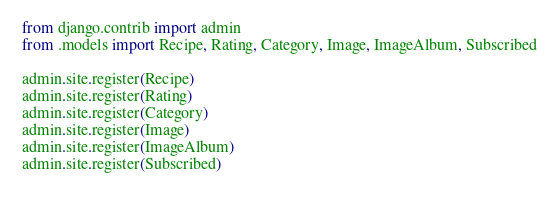<code> <loc_0><loc_0><loc_500><loc_500><_Python_>from django.contrib import admin
from .models import Recipe, Rating, Category, Image, ImageAlbum, Subscribed

admin.site.register(Recipe)
admin.site.register(Rating)
admin.site.register(Category)
admin.site.register(Image)
admin.site.register(ImageAlbum)
admin.site.register(Subscribed)
</code> 